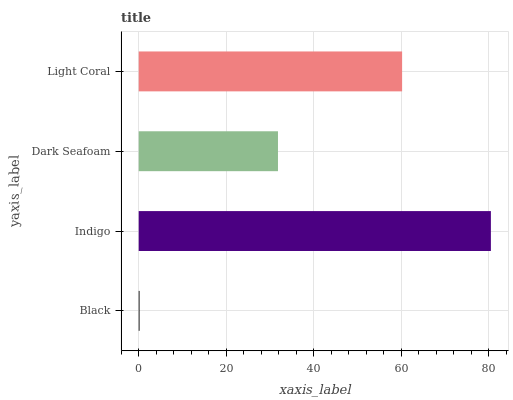Is Black the minimum?
Answer yes or no. Yes. Is Indigo the maximum?
Answer yes or no. Yes. Is Dark Seafoam the minimum?
Answer yes or no. No. Is Dark Seafoam the maximum?
Answer yes or no. No. Is Indigo greater than Dark Seafoam?
Answer yes or no. Yes. Is Dark Seafoam less than Indigo?
Answer yes or no. Yes. Is Dark Seafoam greater than Indigo?
Answer yes or no. No. Is Indigo less than Dark Seafoam?
Answer yes or no. No. Is Light Coral the high median?
Answer yes or no. Yes. Is Dark Seafoam the low median?
Answer yes or no. Yes. Is Indigo the high median?
Answer yes or no. No. Is Light Coral the low median?
Answer yes or no. No. 